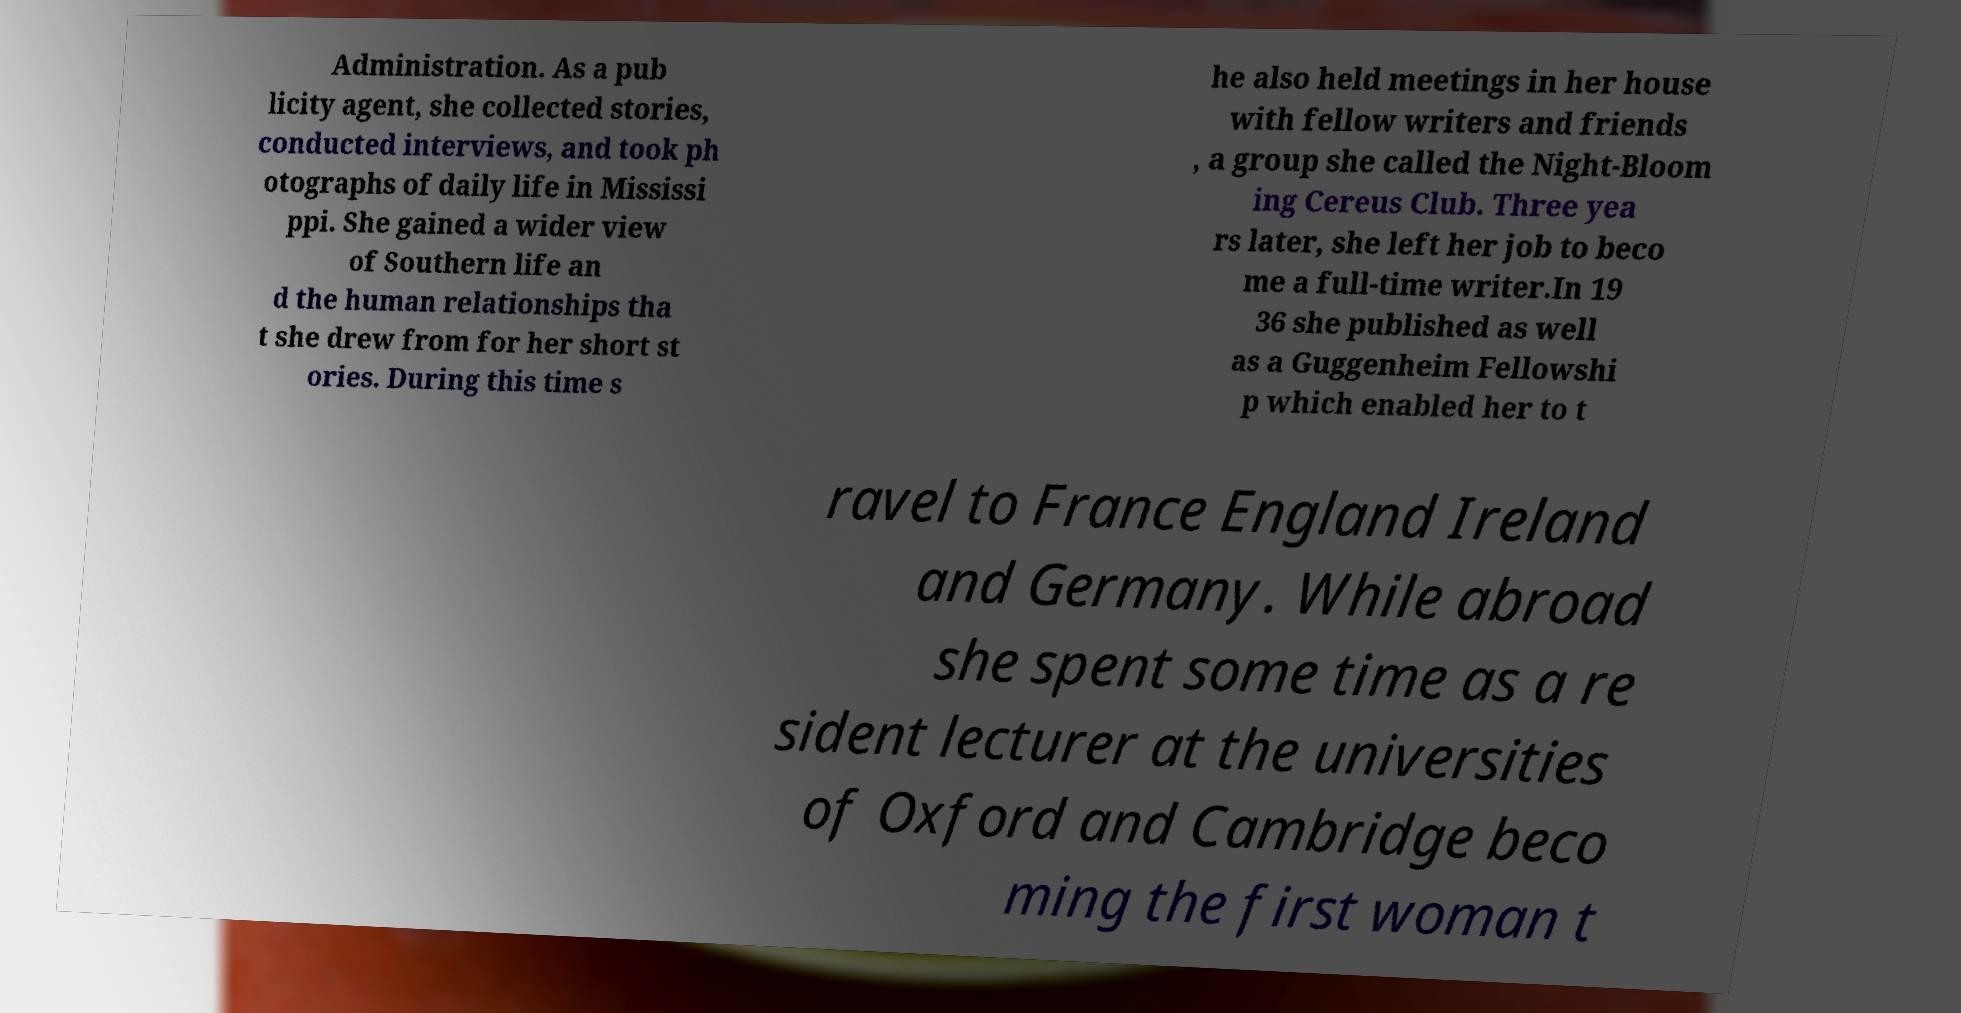Could you assist in decoding the text presented in this image and type it out clearly? Administration. As a pub licity agent, she collected stories, conducted interviews, and took ph otographs of daily life in Mississi ppi. She gained a wider view of Southern life an d the human relationships tha t she drew from for her short st ories. During this time s he also held meetings in her house with fellow writers and friends , a group she called the Night-Bloom ing Cereus Club. Three yea rs later, she left her job to beco me a full-time writer.In 19 36 she published as well as a Guggenheim Fellowshi p which enabled her to t ravel to France England Ireland and Germany. While abroad she spent some time as a re sident lecturer at the universities of Oxford and Cambridge beco ming the first woman t 